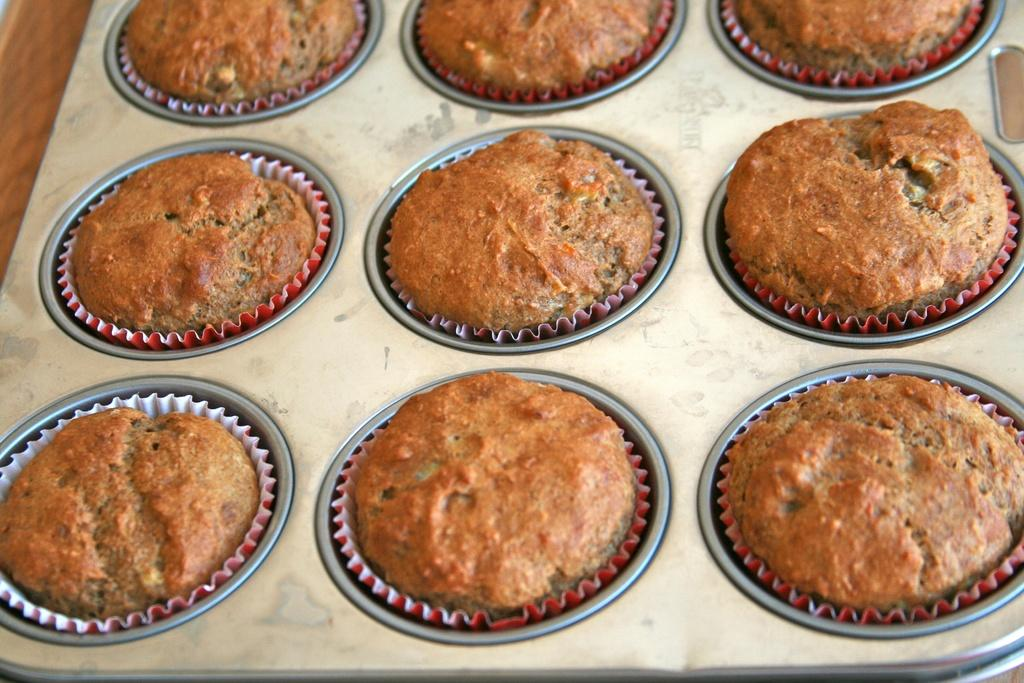What is present in the tray in the image? There are food items in a tray in the image. Can you describe the object located on the top left side of the image? Unfortunately, the provided facts do not give any information about the object on the top left side of the image. What type of distribution can be seen in the image? There is no information about any distribution in the image. Is the sun visible in the image? The provided facts do not mention anything about the sun or the weather, so we cannot determine if the sun is visible in the image. 